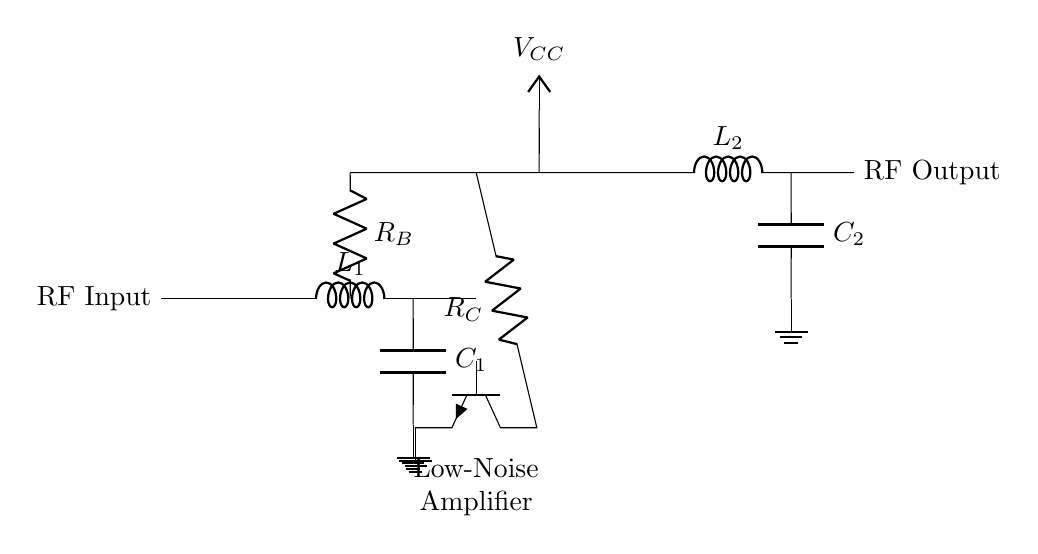What is the function of the component labeled L1? L1 is an inductor used in the matching network to tune the input impedance of the amplifier to maximize power transfer from the antenna.
Answer: Inductor What type of transistor is used in this circuit? The circuit uses an NPN transistor, as indicated by the label npn. This type is commonly used in low-noise amplifier applications due to its amplification properties.
Answer: NPN What is the role of the resistor R_C? R_C is the collector resistor, and it determines the voltage gain of the amplifier by affecting the current flowing through the transistor. A higher value typically results in greater gain.
Answer: Collector resistor What does C2 do in this circuit? C2 is a capacitor that forms a part of the output matching network, which helps to maintain the desired output impedance and prevents signal loss.
Answer: Output coupling How are the input and output signals connected? The input signal is fed into the circuit through the RF input and is amplified by the transistor before being output as RF output; it flows through L1 and C1 as part of the process.
Answer: Input to output via L1 and C1 Why is noise reduction important in this circuit? Noise reduction is crucial because wireless communications in sports equipment require clear signals, and any added noise can distort the transmitted data, degrading performance in applications like telemetry.
Answer: Clear signal transmission 